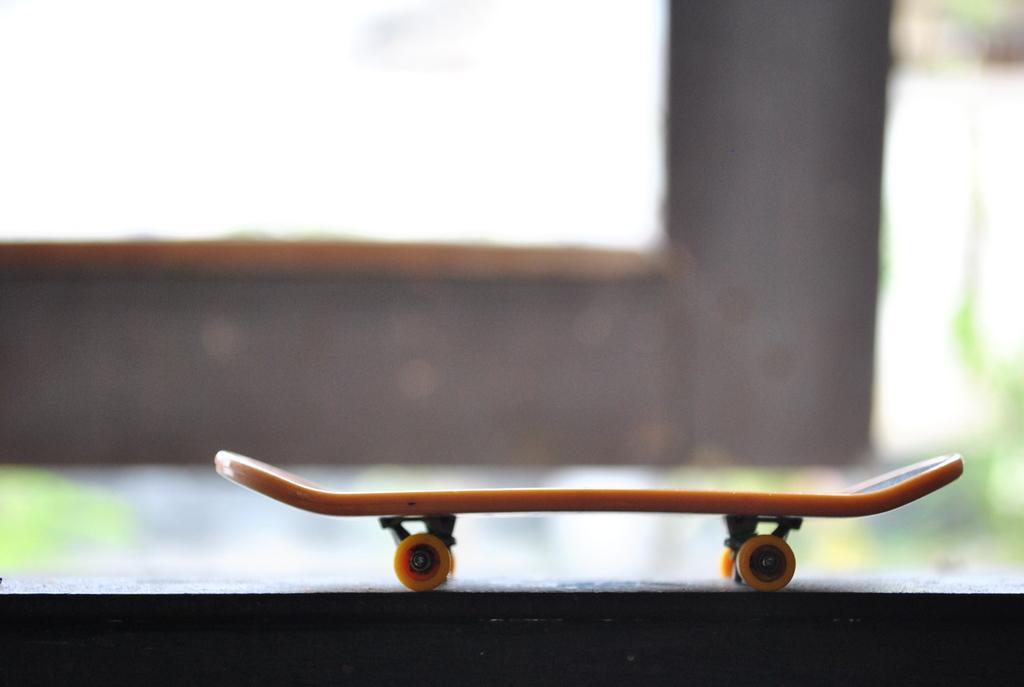How would you summarize this image in a sentence or two? This picture seems to be clicked outside. In the foreground there is a skateboard placed on an object. The background of the image is blurry and we can see there are some objects in the background. 